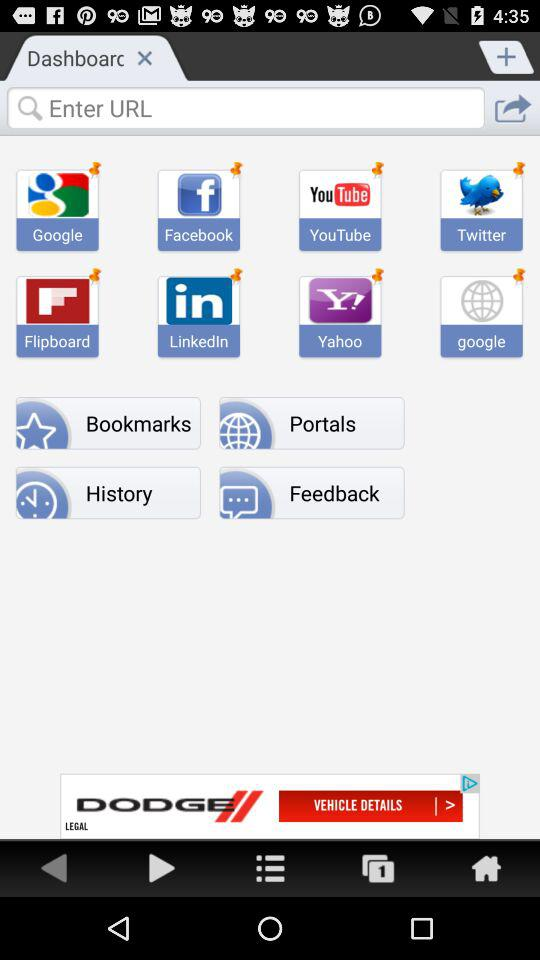What are the mentioned applications? The mentioned applications are "Google", "Facebook", "YouTube", "Twitter", "Flipboard", "LinkedIn", "Yahoo" and "google". 